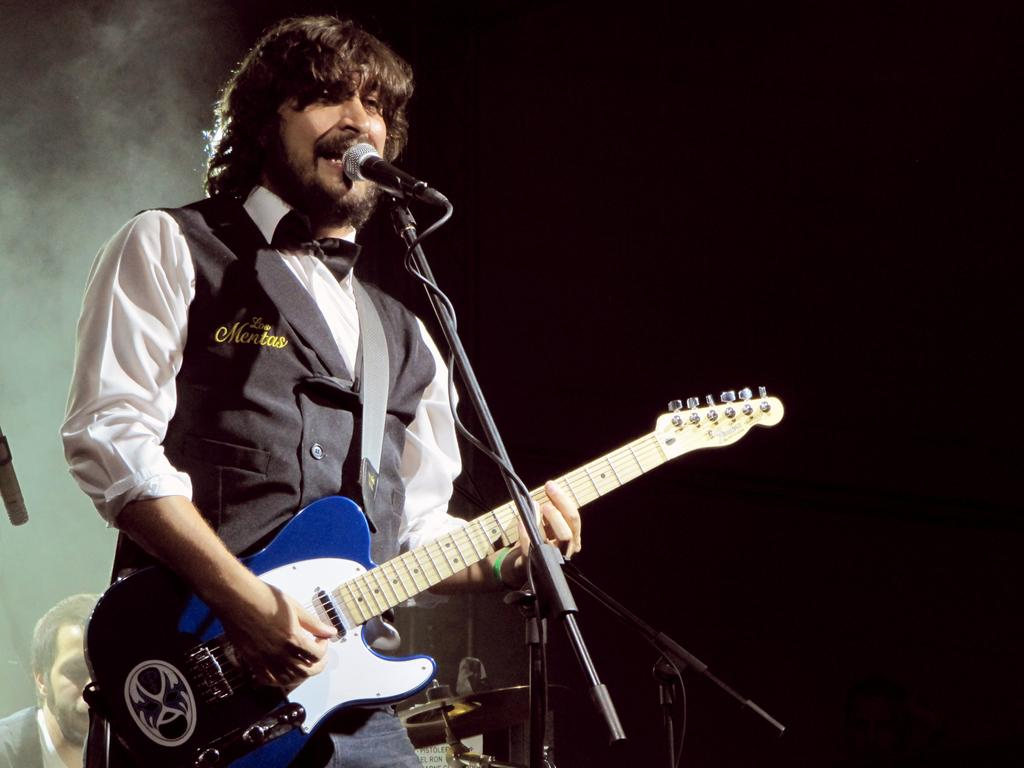What is the man in the image doing? The man is playing the guitar and singing. What instrument is the man holding in the image? The man is holding a guitar in the image. What object is present in the image that is typically used for amplifying sound? There is a microphone in the image. What is the purpose of the stand in the image? The stand is likely used to hold the microphone or other equipment. What can be seen in the background of the image? There is smoke in the background of the image. What type of wool is being spun on the control panel in the image? There is no wool or control panel present in the image. 